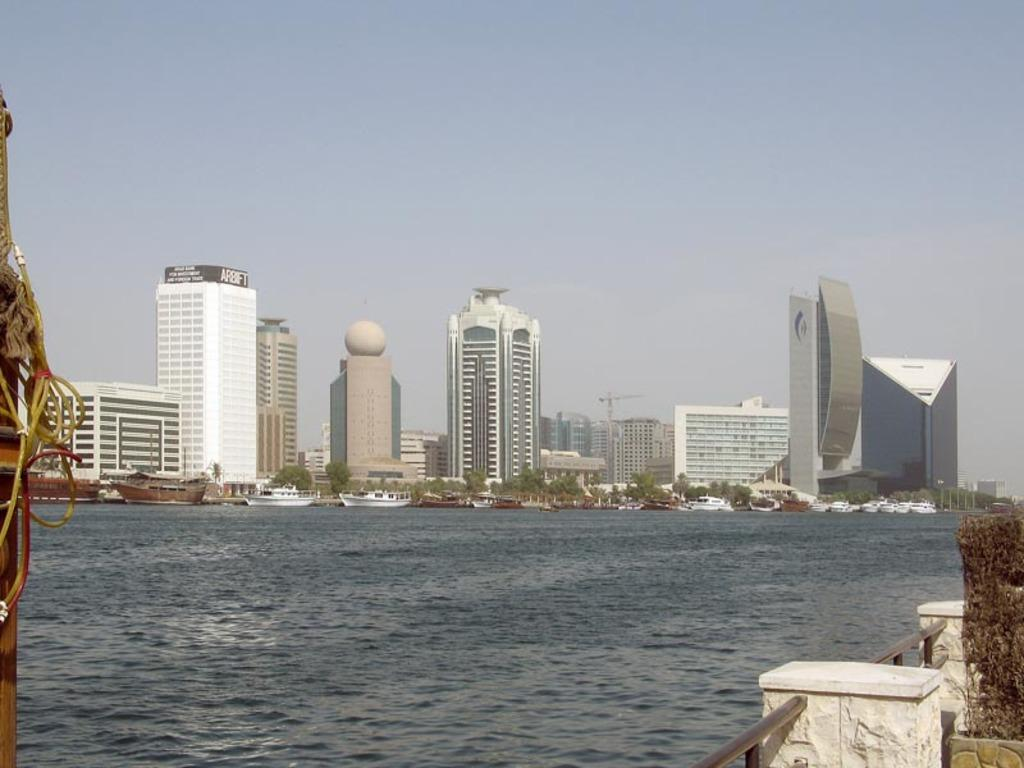What type of natural feature is visible in the image? There is a sea in the image. What structures can be seen behind the sea? There are tall buildings behind the sea. What type of vehicles are present in front of the sea? Ships are present in front of the sea. What is visible in the background of the image? The sky is visible in the background of the image. How much payment is required to experience the sea in the image? There is no payment required to experience the sea in the image, as it is a photograph and not a physical location. 